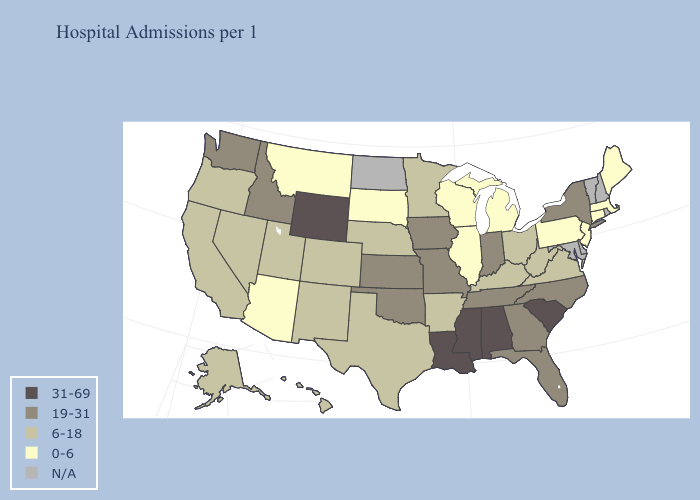Does Wyoming have the highest value in the West?
Short answer required. Yes. What is the highest value in the West ?
Be succinct. 31-69. Name the states that have a value in the range 31-69?
Concise answer only. Alabama, Louisiana, Mississippi, South Carolina, Wyoming. What is the highest value in the Northeast ?
Be succinct. 19-31. What is the value of West Virginia?
Concise answer only. 6-18. Which states have the lowest value in the USA?
Write a very short answer. Arizona, Connecticut, Illinois, Maine, Massachusetts, Michigan, Montana, New Jersey, Pennsylvania, South Dakota, Wisconsin. Which states hav the highest value in the MidWest?
Answer briefly. Indiana, Iowa, Kansas, Missouri. Which states have the lowest value in the USA?
Write a very short answer. Arizona, Connecticut, Illinois, Maine, Massachusetts, Michigan, Montana, New Jersey, Pennsylvania, South Dakota, Wisconsin. What is the highest value in the West ?
Answer briefly. 31-69. What is the lowest value in states that border Nebraska?
Quick response, please. 0-6. Name the states that have a value in the range 6-18?
Answer briefly. Alaska, Arkansas, California, Colorado, Hawaii, Kentucky, Minnesota, Nebraska, Nevada, New Mexico, Ohio, Oregon, Texas, Utah, Virginia, West Virginia. What is the value of Washington?
Keep it brief. 19-31. Which states have the lowest value in the South?
Short answer required. Arkansas, Kentucky, Texas, Virginia, West Virginia. Which states have the lowest value in the USA?
Quick response, please. Arizona, Connecticut, Illinois, Maine, Massachusetts, Michigan, Montana, New Jersey, Pennsylvania, South Dakota, Wisconsin. What is the highest value in states that border Oklahoma?
Write a very short answer. 19-31. 